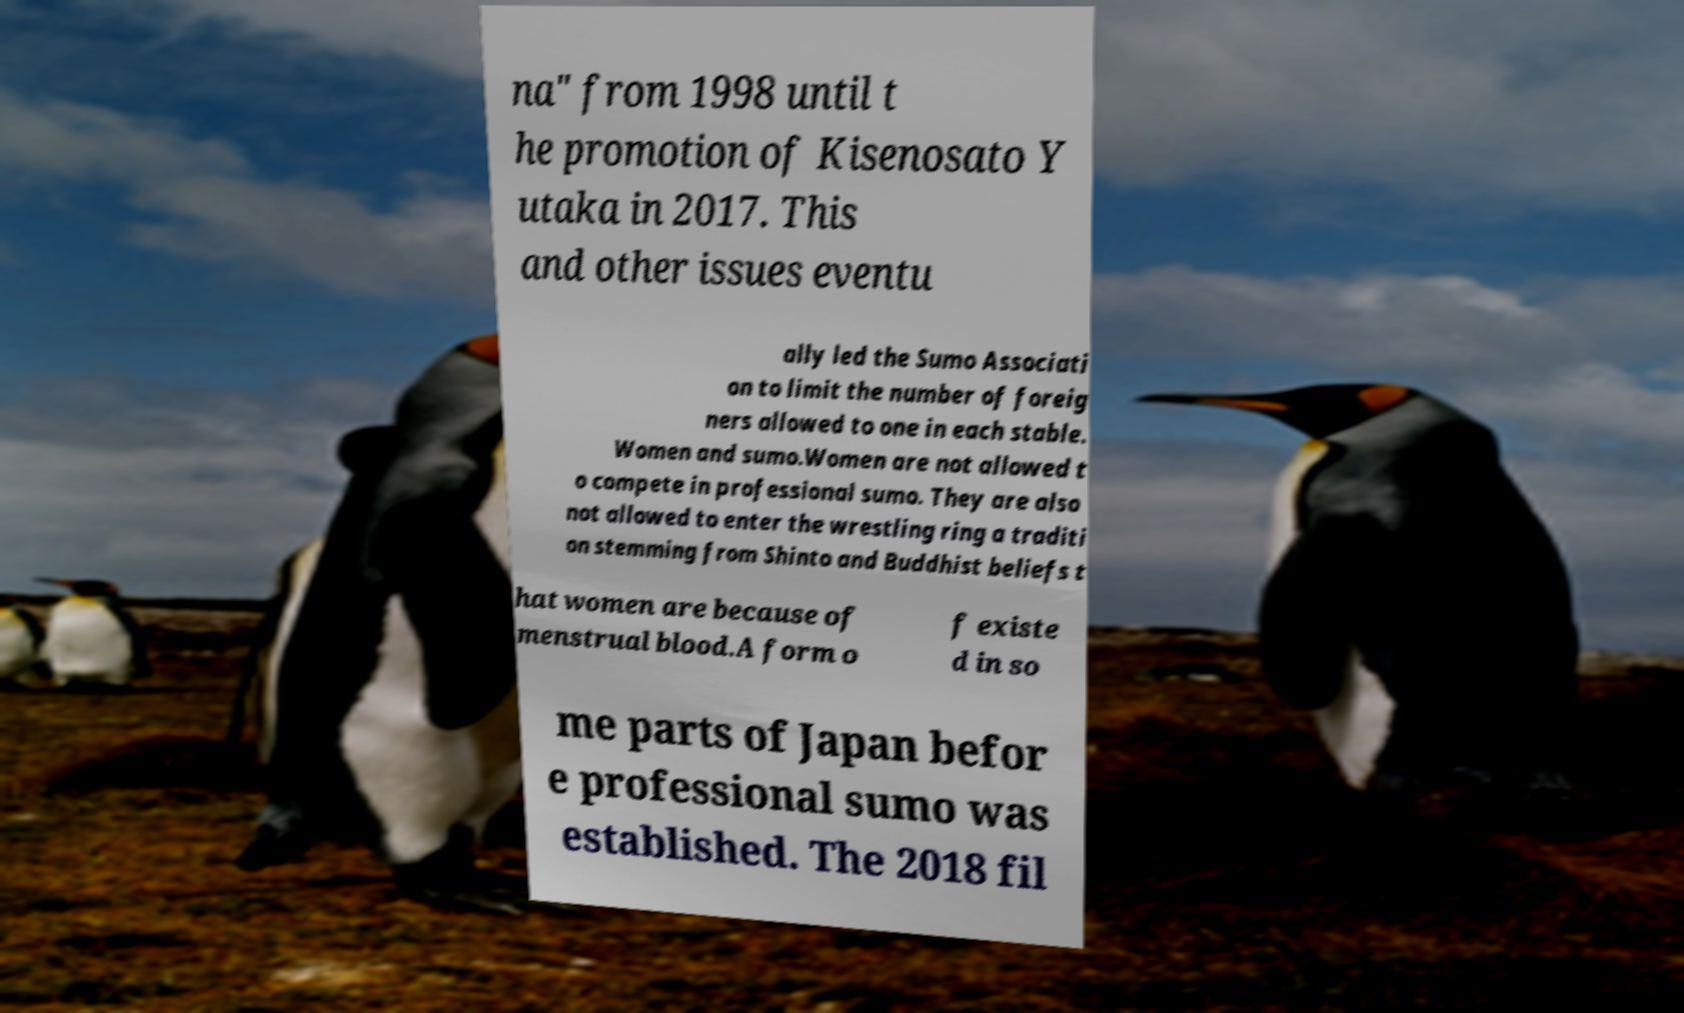Please identify and transcribe the text found in this image. na" from 1998 until t he promotion of Kisenosato Y utaka in 2017. This and other issues eventu ally led the Sumo Associati on to limit the number of foreig ners allowed to one in each stable. Women and sumo.Women are not allowed t o compete in professional sumo. They are also not allowed to enter the wrestling ring a traditi on stemming from Shinto and Buddhist beliefs t hat women are because of menstrual blood.A form o f existe d in so me parts of Japan befor e professional sumo was established. The 2018 fil 